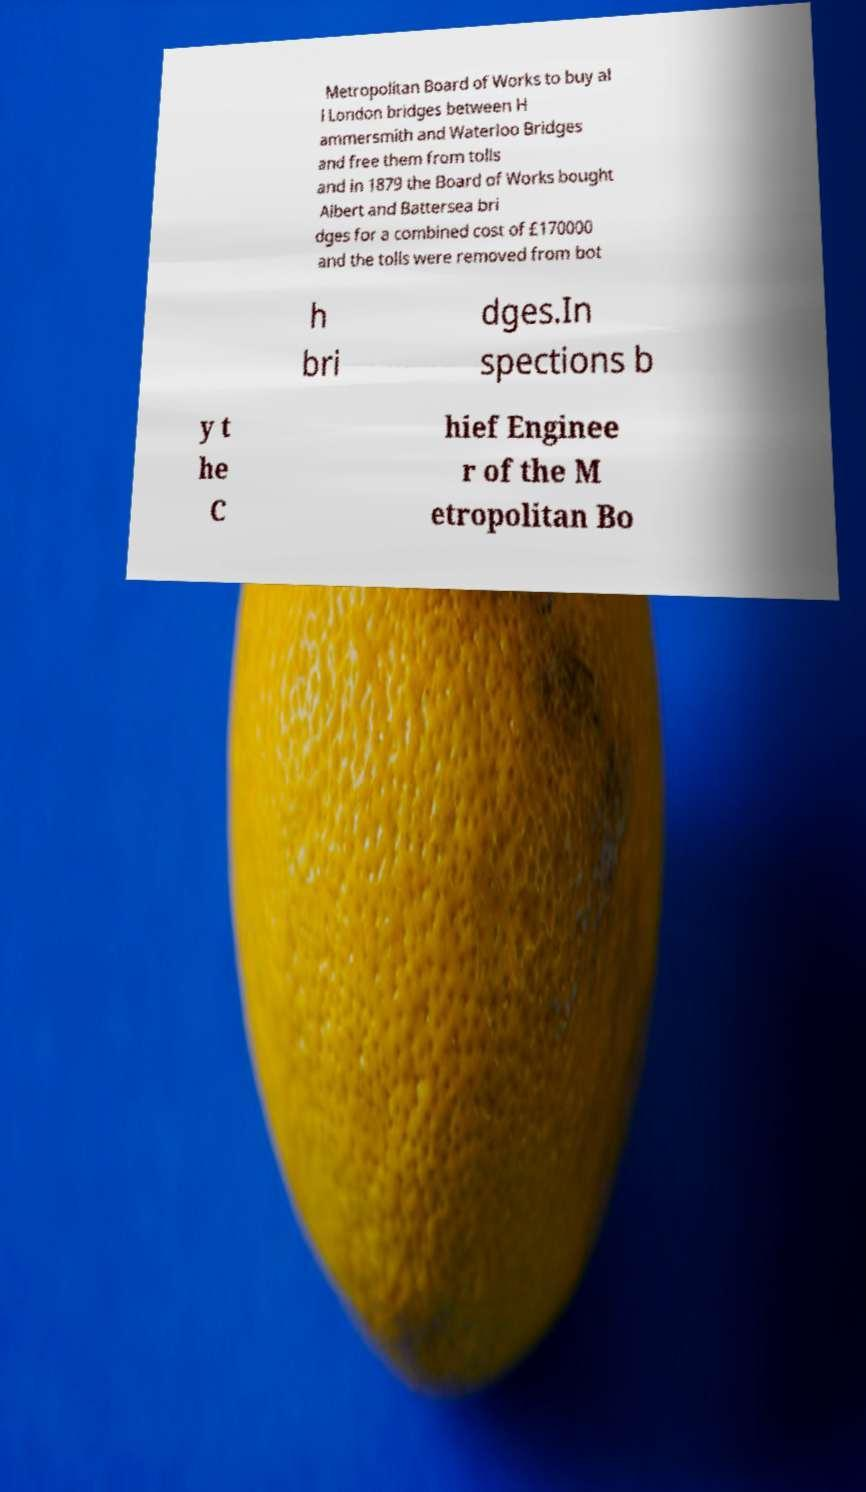Can you accurately transcribe the text from the provided image for me? Metropolitan Board of Works to buy al l London bridges between H ammersmith and Waterloo Bridges and free them from tolls and in 1879 the Board of Works bought Albert and Battersea bri dges for a combined cost of £170000 and the tolls were removed from bot h bri dges.In spections b y t he C hief Enginee r of the M etropolitan Bo 